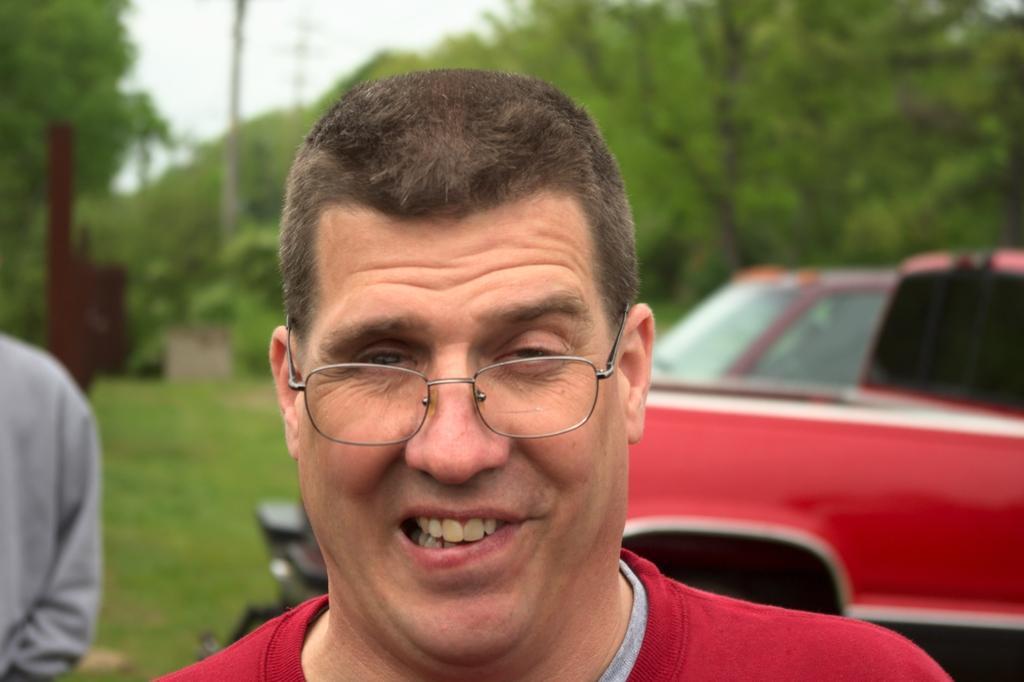How would you summarize this image in a sentence or two? In this picture we can observe a person wearing a red color T shirt and spectacles. He is smiling. On the left side there is another person standing. In the background we can observe a red color car parked. There are trees and a sky in the background. 